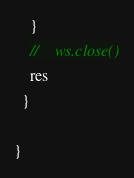Convert code to text. <code><loc_0><loc_0><loc_500><loc_500><_Scala_>    }
    //    ws.close()
    res
  }

}
</code> 